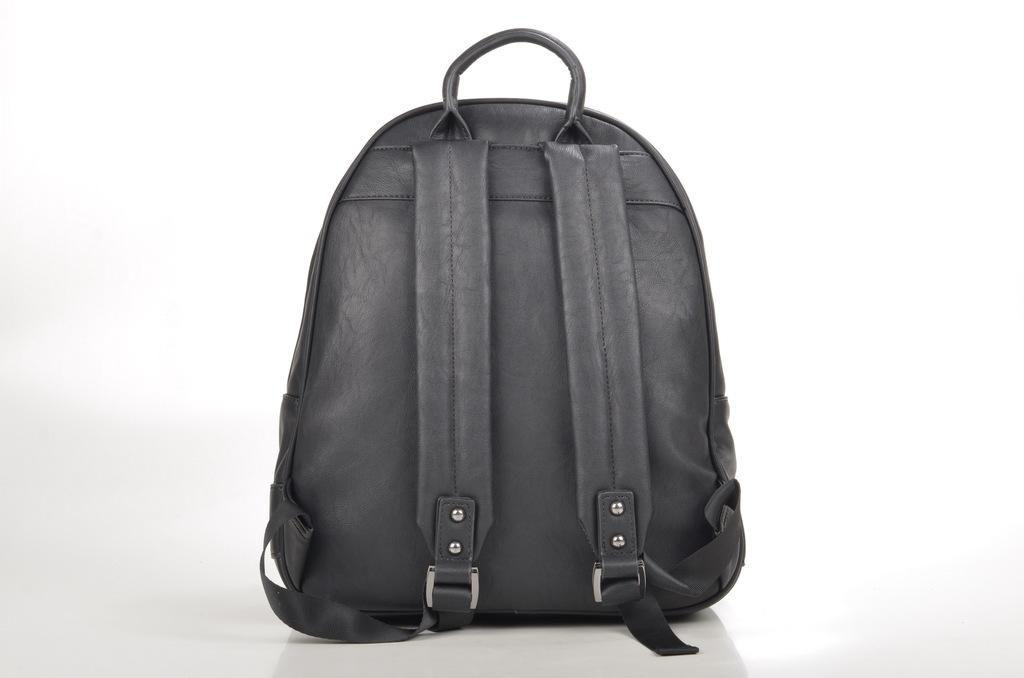What type of bag is visible in the image? There is a backpack in the image. What color is the backpack? The backpack is black in color. What type of treatment is being administered to the backpack in the image? There is no treatment being administered to the backpack in the image, as it is an inanimate object. 